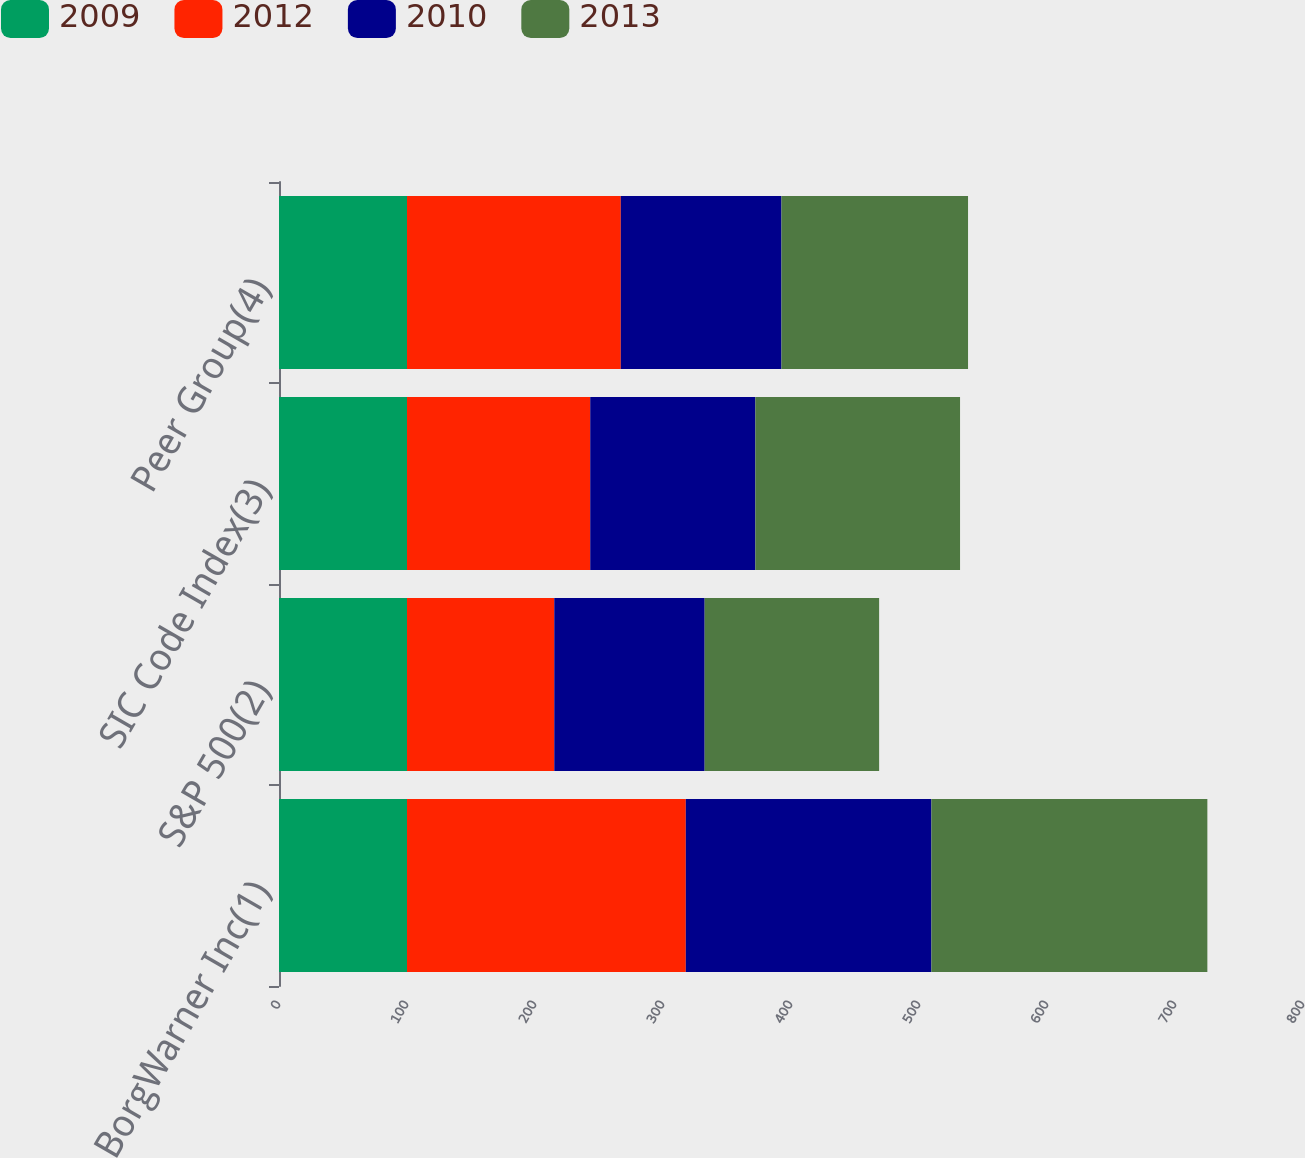<chart> <loc_0><loc_0><loc_500><loc_500><stacked_bar_chart><ecel><fcel>BorgWarner Inc(1)<fcel>S&P 500(2)<fcel>SIC Code Index(3)<fcel>Peer Group(4)<nl><fcel>2009<fcel>100<fcel>100<fcel>100<fcel>100<nl><fcel>2012<fcel>217.82<fcel>115.06<fcel>143.15<fcel>167.02<nl><fcel>2010<fcel>191.87<fcel>117.49<fcel>129.03<fcel>125.53<nl><fcel>2013<fcel>215.59<fcel>136.3<fcel>159.89<fcel>145.76<nl></chart> 